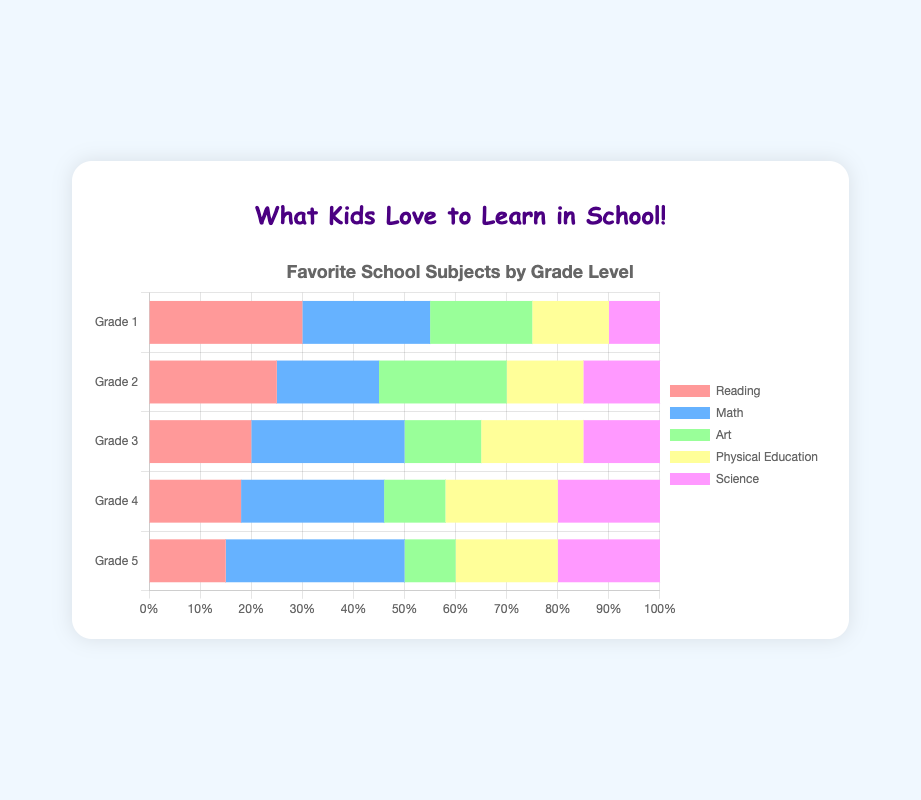Which grade level has the most students favoring Reading? By comparing the heights of the bars labeled "Reading" for each grade level, we see that Grade 1 has the tallest bar for Reading at 30%.
Answer: Grade 1 How many more students in Grade 3 prefer Math over Science? For Grade 3, the Math bar is at 30%, and the Science bar is at 15%. The difference is 30% - 15% = 15%.
Answer: 15% Between Grade 2 and Grade 4, which grade has a higher percentage of students who like Art? The Art bar for Grade 2 shows 25%, while for Grade 4, it shows 12%. Thus, Grade 2 has a higher percentage.
Answer: Grade 2 What's the total percentage of students in Grade 5 who prefer either Math or Science? In Grade 5, the Math bar is at 35% and the Science bar is at 20%. Adding these together gives 35% + 20% = 55%.
Answer: 55% If we average the percentages of students who like Physical Education across all grades, what is the average percentage? The Physical Education percentages are 15%, 15%, 20%, 22%, and 20% for Grades 1 to 5. Summing these gives 92%, and dividing by 5 (the number of grades) gives 92% / 5 = 18.4%.
Answer: 18.4% In which grade is the difference between the highest and the lowest favorite subject the greatest? For each grade, find the highest and lowest percentages: Grade 1 (30% - 10% = 20%), Grade 2 (25% - 15% = 10%), Grade 3 (30% - 15% = 15%), Grade 4 (28% - 12% = 16%), Grade 5 (35% - 10% = 25%). The largest difference is in Grade 5.
Answer: Grade 5 Compare the number of students in Grade 2 who like Reading with those who like Science. Which is higher? In Grade 2, the Reading bar is at 25% and the Science bar is at 15%. Reading is higher.
Answer: Reading What's the combined percentage of students in Grade 4 who favor Math and Physical Education? For Grade 4, the Math bar shows 28% and the Physical Education bar shows 22%. Adding these together gives 28% + 22% = 50%.
Answer: 50% How does the popularity of Science change from Grade 1 to Grade 5? In Grade 1, Science is at 10%. The percentages for the following grades are 15%, 15%, 20%, and 20%. From Grade 1 to Grade 5, the popularity increases.
Answer: Increases Which subject is consistently liked the least across all grades? Looking at each grade, the lowest bars are: Grade 1: Science (10%), Grade 2: Science (15%), Grade 3: Art (15%), Grade 4: Art (12%), Grade 5: Art (10%). Science and Art are the least, but Art has lower values overall.
Answer: Art 